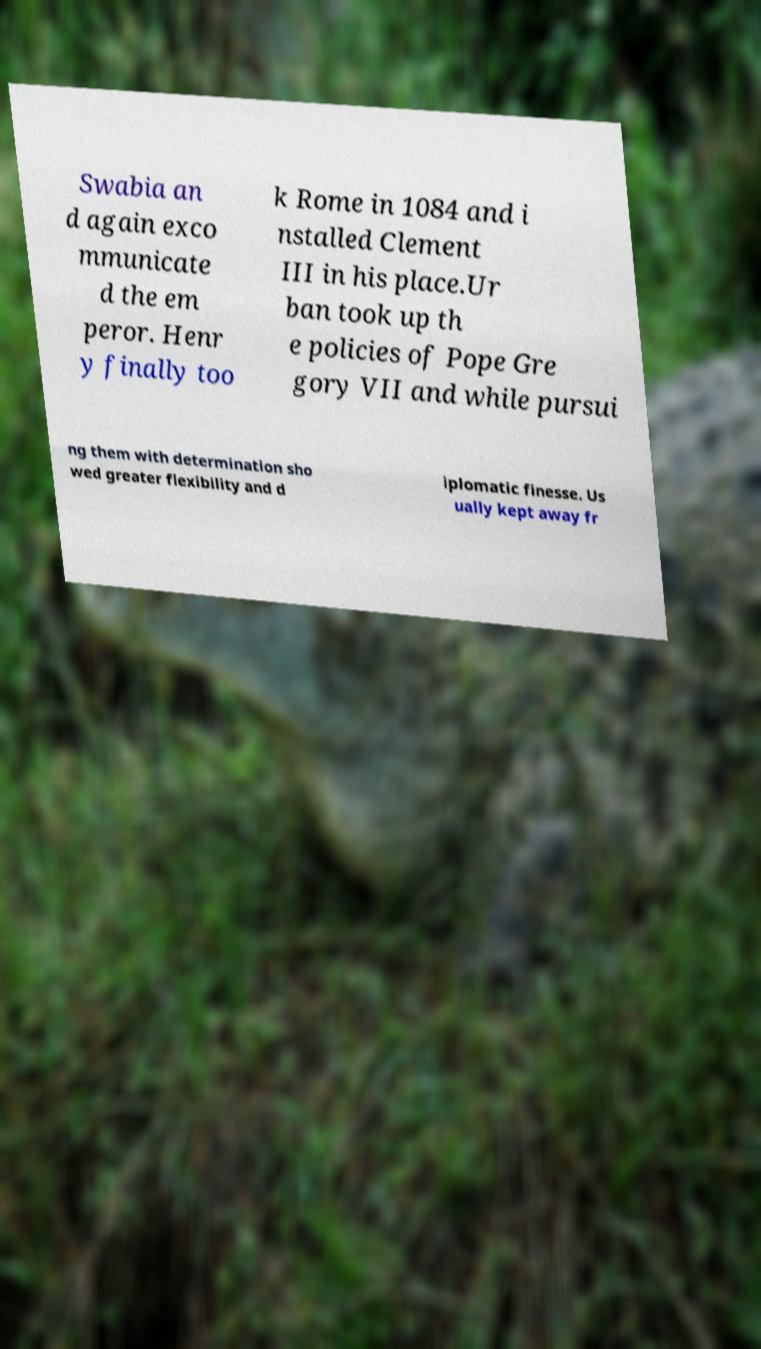Can you accurately transcribe the text from the provided image for me? Swabia an d again exco mmunicate d the em peror. Henr y finally too k Rome in 1084 and i nstalled Clement III in his place.Ur ban took up th e policies of Pope Gre gory VII and while pursui ng them with determination sho wed greater flexibility and d iplomatic finesse. Us ually kept away fr 